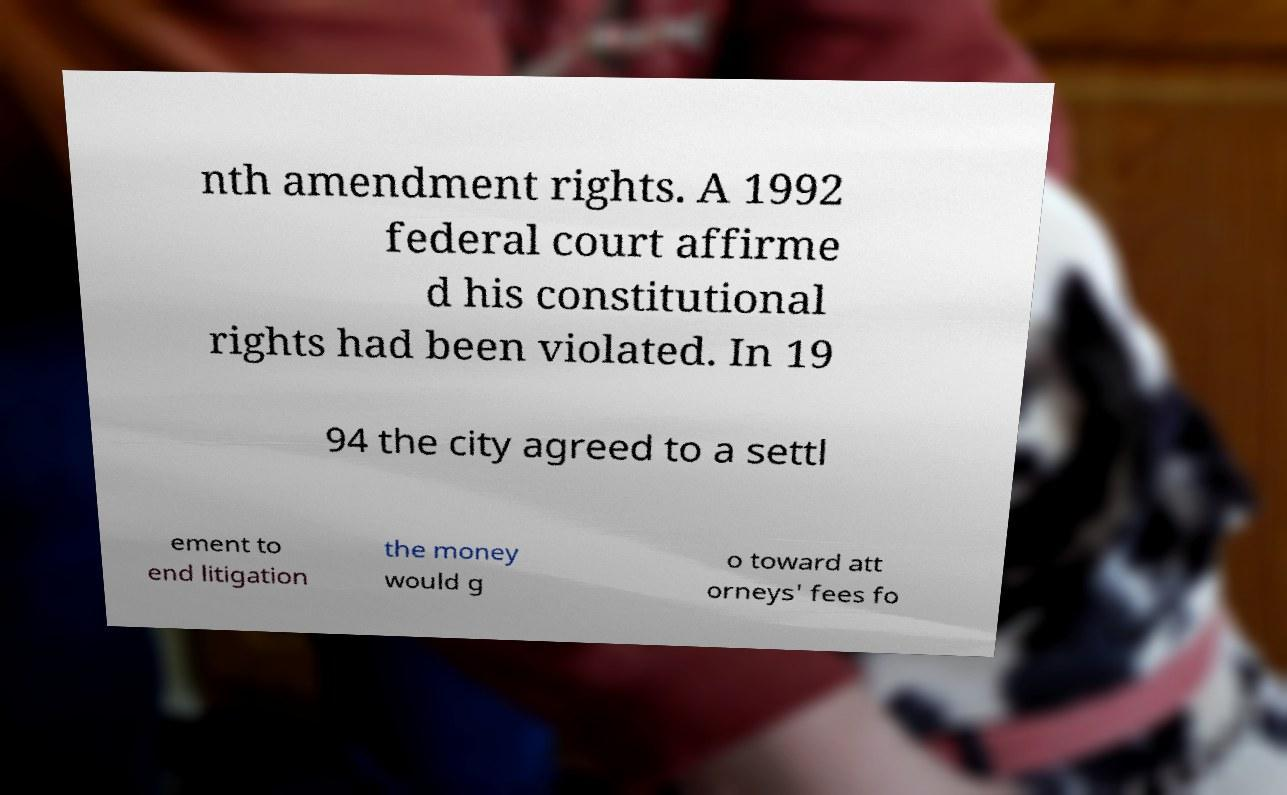For documentation purposes, I need the text within this image transcribed. Could you provide that? nth amendment rights. A 1992 federal court affirme d his constitutional rights had been violated. In 19 94 the city agreed to a settl ement to end litigation the money would g o toward att orneys' fees fo 